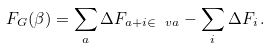<formula> <loc_0><loc_0><loc_500><loc_500>F _ { G } ( \beta ) = \sum _ { a } \Delta F _ { a + i \in \ v a } - \sum _ { i } \Delta F _ { i } \, .</formula> 